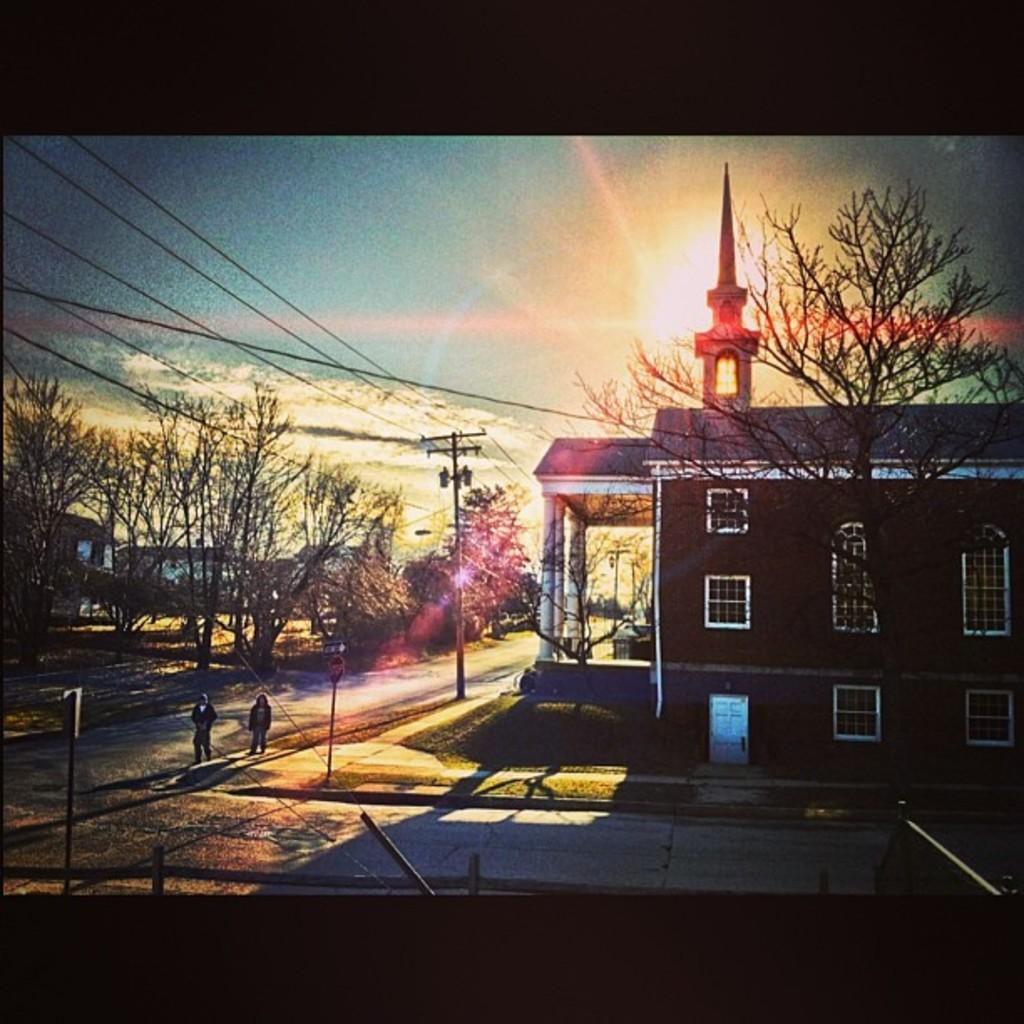In one or two sentences, can you explain what this image depicts? In this image, we can see some trees. There is a roof house on the right side of the image. There are two persons walking on the road. There are poles beside the road. There is a sky at the top of the image. 